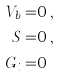Convert formula to latex. <formula><loc_0><loc_0><loc_500><loc_500>V _ { b } = & 0 \, , \\ S = & 0 \, , \\ G _ { i } = & 0 \,</formula> 